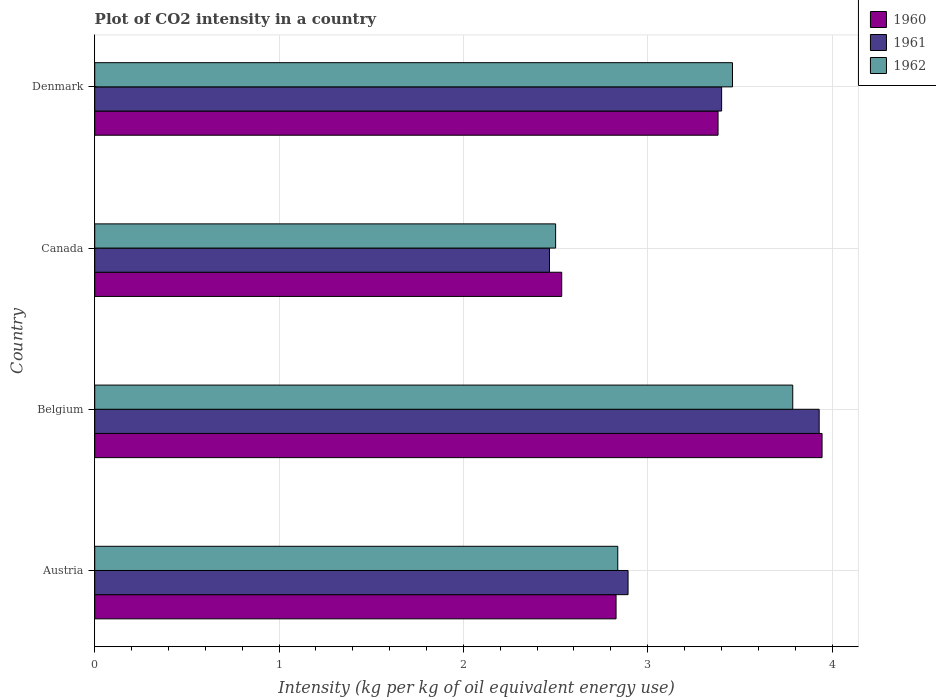How many groups of bars are there?
Give a very brief answer. 4. Are the number of bars per tick equal to the number of legend labels?
Make the answer very short. Yes. Are the number of bars on each tick of the Y-axis equal?
Provide a succinct answer. Yes. How many bars are there on the 4th tick from the bottom?
Give a very brief answer. 3. What is the CO2 intensity in in 1960 in Austria?
Your answer should be compact. 2.83. Across all countries, what is the maximum CO2 intensity in in 1962?
Offer a very short reply. 3.79. Across all countries, what is the minimum CO2 intensity in in 1962?
Provide a succinct answer. 2.5. In which country was the CO2 intensity in in 1960 maximum?
Ensure brevity in your answer.  Belgium. In which country was the CO2 intensity in in 1960 minimum?
Your answer should be compact. Canada. What is the total CO2 intensity in in 1961 in the graph?
Offer a very short reply. 12.69. What is the difference between the CO2 intensity in in 1961 in Austria and that in Belgium?
Keep it short and to the point. -1.04. What is the difference between the CO2 intensity in in 1960 in Denmark and the CO2 intensity in in 1962 in Belgium?
Your response must be concise. -0.41. What is the average CO2 intensity in in 1962 per country?
Your answer should be compact. 3.15. What is the difference between the CO2 intensity in in 1960 and CO2 intensity in in 1961 in Austria?
Provide a succinct answer. -0.07. In how many countries, is the CO2 intensity in in 1960 greater than 1.4 kg?
Your answer should be compact. 4. What is the ratio of the CO2 intensity in in 1960 in Austria to that in Canada?
Provide a short and direct response. 1.12. Is the CO2 intensity in in 1961 in Austria less than that in Belgium?
Keep it short and to the point. Yes. Is the difference between the CO2 intensity in in 1960 in Austria and Canada greater than the difference between the CO2 intensity in in 1961 in Austria and Canada?
Provide a succinct answer. No. What is the difference between the highest and the second highest CO2 intensity in in 1962?
Provide a succinct answer. 0.33. What is the difference between the highest and the lowest CO2 intensity in in 1960?
Keep it short and to the point. 1.41. Is it the case that in every country, the sum of the CO2 intensity in in 1960 and CO2 intensity in in 1962 is greater than the CO2 intensity in in 1961?
Your answer should be very brief. Yes. Are all the bars in the graph horizontal?
Offer a terse response. Yes. How many countries are there in the graph?
Keep it short and to the point. 4. What is the difference between two consecutive major ticks on the X-axis?
Ensure brevity in your answer.  1. Are the values on the major ticks of X-axis written in scientific E-notation?
Make the answer very short. No. Does the graph contain any zero values?
Offer a terse response. No. Where does the legend appear in the graph?
Give a very brief answer. Top right. What is the title of the graph?
Ensure brevity in your answer.  Plot of CO2 intensity in a country. What is the label or title of the X-axis?
Your answer should be very brief. Intensity (kg per kg of oil equivalent energy use). What is the Intensity (kg per kg of oil equivalent energy use) of 1960 in Austria?
Provide a short and direct response. 2.83. What is the Intensity (kg per kg of oil equivalent energy use) in 1961 in Austria?
Provide a succinct answer. 2.89. What is the Intensity (kg per kg of oil equivalent energy use) of 1962 in Austria?
Offer a terse response. 2.84. What is the Intensity (kg per kg of oil equivalent energy use) of 1960 in Belgium?
Provide a succinct answer. 3.95. What is the Intensity (kg per kg of oil equivalent energy use) of 1961 in Belgium?
Keep it short and to the point. 3.93. What is the Intensity (kg per kg of oil equivalent energy use) of 1962 in Belgium?
Your answer should be compact. 3.79. What is the Intensity (kg per kg of oil equivalent energy use) in 1960 in Canada?
Your answer should be very brief. 2.53. What is the Intensity (kg per kg of oil equivalent energy use) of 1961 in Canada?
Your answer should be compact. 2.47. What is the Intensity (kg per kg of oil equivalent energy use) of 1962 in Canada?
Your response must be concise. 2.5. What is the Intensity (kg per kg of oil equivalent energy use) in 1960 in Denmark?
Offer a very short reply. 3.38. What is the Intensity (kg per kg of oil equivalent energy use) in 1961 in Denmark?
Your response must be concise. 3.4. What is the Intensity (kg per kg of oil equivalent energy use) of 1962 in Denmark?
Offer a very short reply. 3.46. Across all countries, what is the maximum Intensity (kg per kg of oil equivalent energy use) in 1960?
Your response must be concise. 3.95. Across all countries, what is the maximum Intensity (kg per kg of oil equivalent energy use) of 1961?
Ensure brevity in your answer.  3.93. Across all countries, what is the maximum Intensity (kg per kg of oil equivalent energy use) of 1962?
Provide a short and direct response. 3.79. Across all countries, what is the minimum Intensity (kg per kg of oil equivalent energy use) of 1960?
Ensure brevity in your answer.  2.53. Across all countries, what is the minimum Intensity (kg per kg of oil equivalent energy use) in 1961?
Make the answer very short. 2.47. Across all countries, what is the minimum Intensity (kg per kg of oil equivalent energy use) of 1962?
Give a very brief answer. 2.5. What is the total Intensity (kg per kg of oil equivalent energy use) in 1960 in the graph?
Provide a succinct answer. 12.69. What is the total Intensity (kg per kg of oil equivalent energy use) in 1961 in the graph?
Provide a succinct answer. 12.69. What is the total Intensity (kg per kg of oil equivalent energy use) of 1962 in the graph?
Ensure brevity in your answer.  12.58. What is the difference between the Intensity (kg per kg of oil equivalent energy use) in 1960 in Austria and that in Belgium?
Give a very brief answer. -1.12. What is the difference between the Intensity (kg per kg of oil equivalent energy use) of 1961 in Austria and that in Belgium?
Your response must be concise. -1.04. What is the difference between the Intensity (kg per kg of oil equivalent energy use) of 1962 in Austria and that in Belgium?
Your answer should be compact. -0.95. What is the difference between the Intensity (kg per kg of oil equivalent energy use) of 1960 in Austria and that in Canada?
Your response must be concise. 0.29. What is the difference between the Intensity (kg per kg of oil equivalent energy use) in 1961 in Austria and that in Canada?
Give a very brief answer. 0.43. What is the difference between the Intensity (kg per kg of oil equivalent energy use) of 1962 in Austria and that in Canada?
Provide a succinct answer. 0.34. What is the difference between the Intensity (kg per kg of oil equivalent energy use) of 1960 in Austria and that in Denmark?
Make the answer very short. -0.55. What is the difference between the Intensity (kg per kg of oil equivalent energy use) in 1961 in Austria and that in Denmark?
Give a very brief answer. -0.51. What is the difference between the Intensity (kg per kg of oil equivalent energy use) in 1962 in Austria and that in Denmark?
Provide a short and direct response. -0.62. What is the difference between the Intensity (kg per kg of oil equivalent energy use) of 1960 in Belgium and that in Canada?
Offer a terse response. 1.41. What is the difference between the Intensity (kg per kg of oil equivalent energy use) of 1961 in Belgium and that in Canada?
Offer a terse response. 1.46. What is the difference between the Intensity (kg per kg of oil equivalent energy use) in 1962 in Belgium and that in Canada?
Your response must be concise. 1.29. What is the difference between the Intensity (kg per kg of oil equivalent energy use) of 1960 in Belgium and that in Denmark?
Provide a succinct answer. 0.56. What is the difference between the Intensity (kg per kg of oil equivalent energy use) in 1961 in Belgium and that in Denmark?
Your answer should be very brief. 0.53. What is the difference between the Intensity (kg per kg of oil equivalent energy use) in 1962 in Belgium and that in Denmark?
Make the answer very short. 0.33. What is the difference between the Intensity (kg per kg of oil equivalent energy use) of 1960 in Canada and that in Denmark?
Ensure brevity in your answer.  -0.85. What is the difference between the Intensity (kg per kg of oil equivalent energy use) in 1961 in Canada and that in Denmark?
Give a very brief answer. -0.93. What is the difference between the Intensity (kg per kg of oil equivalent energy use) in 1962 in Canada and that in Denmark?
Make the answer very short. -0.96. What is the difference between the Intensity (kg per kg of oil equivalent energy use) of 1960 in Austria and the Intensity (kg per kg of oil equivalent energy use) of 1961 in Belgium?
Offer a terse response. -1.1. What is the difference between the Intensity (kg per kg of oil equivalent energy use) in 1960 in Austria and the Intensity (kg per kg of oil equivalent energy use) in 1962 in Belgium?
Keep it short and to the point. -0.96. What is the difference between the Intensity (kg per kg of oil equivalent energy use) of 1961 in Austria and the Intensity (kg per kg of oil equivalent energy use) of 1962 in Belgium?
Your answer should be compact. -0.89. What is the difference between the Intensity (kg per kg of oil equivalent energy use) in 1960 in Austria and the Intensity (kg per kg of oil equivalent energy use) in 1961 in Canada?
Give a very brief answer. 0.36. What is the difference between the Intensity (kg per kg of oil equivalent energy use) in 1960 in Austria and the Intensity (kg per kg of oil equivalent energy use) in 1962 in Canada?
Offer a terse response. 0.33. What is the difference between the Intensity (kg per kg of oil equivalent energy use) of 1961 in Austria and the Intensity (kg per kg of oil equivalent energy use) of 1962 in Canada?
Your answer should be very brief. 0.39. What is the difference between the Intensity (kg per kg of oil equivalent energy use) of 1960 in Austria and the Intensity (kg per kg of oil equivalent energy use) of 1961 in Denmark?
Offer a very short reply. -0.57. What is the difference between the Intensity (kg per kg of oil equivalent energy use) of 1960 in Austria and the Intensity (kg per kg of oil equivalent energy use) of 1962 in Denmark?
Provide a succinct answer. -0.63. What is the difference between the Intensity (kg per kg of oil equivalent energy use) in 1961 in Austria and the Intensity (kg per kg of oil equivalent energy use) in 1962 in Denmark?
Offer a terse response. -0.57. What is the difference between the Intensity (kg per kg of oil equivalent energy use) of 1960 in Belgium and the Intensity (kg per kg of oil equivalent energy use) of 1961 in Canada?
Make the answer very short. 1.48. What is the difference between the Intensity (kg per kg of oil equivalent energy use) in 1960 in Belgium and the Intensity (kg per kg of oil equivalent energy use) in 1962 in Canada?
Offer a very short reply. 1.45. What is the difference between the Intensity (kg per kg of oil equivalent energy use) in 1961 in Belgium and the Intensity (kg per kg of oil equivalent energy use) in 1962 in Canada?
Offer a terse response. 1.43. What is the difference between the Intensity (kg per kg of oil equivalent energy use) in 1960 in Belgium and the Intensity (kg per kg of oil equivalent energy use) in 1961 in Denmark?
Ensure brevity in your answer.  0.54. What is the difference between the Intensity (kg per kg of oil equivalent energy use) of 1960 in Belgium and the Intensity (kg per kg of oil equivalent energy use) of 1962 in Denmark?
Your answer should be very brief. 0.49. What is the difference between the Intensity (kg per kg of oil equivalent energy use) in 1961 in Belgium and the Intensity (kg per kg of oil equivalent energy use) in 1962 in Denmark?
Offer a terse response. 0.47. What is the difference between the Intensity (kg per kg of oil equivalent energy use) in 1960 in Canada and the Intensity (kg per kg of oil equivalent energy use) in 1961 in Denmark?
Offer a very short reply. -0.87. What is the difference between the Intensity (kg per kg of oil equivalent energy use) in 1960 in Canada and the Intensity (kg per kg of oil equivalent energy use) in 1962 in Denmark?
Keep it short and to the point. -0.93. What is the difference between the Intensity (kg per kg of oil equivalent energy use) in 1961 in Canada and the Intensity (kg per kg of oil equivalent energy use) in 1962 in Denmark?
Your answer should be compact. -0.99. What is the average Intensity (kg per kg of oil equivalent energy use) in 1960 per country?
Keep it short and to the point. 3.17. What is the average Intensity (kg per kg of oil equivalent energy use) in 1961 per country?
Keep it short and to the point. 3.17. What is the average Intensity (kg per kg of oil equivalent energy use) in 1962 per country?
Make the answer very short. 3.15. What is the difference between the Intensity (kg per kg of oil equivalent energy use) in 1960 and Intensity (kg per kg of oil equivalent energy use) in 1961 in Austria?
Provide a succinct answer. -0.07. What is the difference between the Intensity (kg per kg of oil equivalent energy use) of 1960 and Intensity (kg per kg of oil equivalent energy use) of 1962 in Austria?
Ensure brevity in your answer.  -0.01. What is the difference between the Intensity (kg per kg of oil equivalent energy use) in 1961 and Intensity (kg per kg of oil equivalent energy use) in 1962 in Austria?
Make the answer very short. 0.06. What is the difference between the Intensity (kg per kg of oil equivalent energy use) in 1960 and Intensity (kg per kg of oil equivalent energy use) in 1961 in Belgium?
Your answer should be compact. 0.02. What is the difference between the Intensity (kg per kg of oil equivalent energy use) in 1960 and Intensity (kg per kg of oil equivalent energy use) in 1962 in Belgium?
Give a very brief answer. 0.16. What is the difference between the Intensity (kg per kg of oil equivalent energy use) in 1961 and Intensity (kg per kg of oil equivalent energy use) in 1962 in Belgium?
Offer a terse response. 0.14. What is the difference between the Intensity (kg per kg of oil equivalent energy use) in 1960 and Intensity (kg per kg of oil equivalent energy use) in 1961 in Canada?
Offer a terse response. 0.07. What is the difference between the Intensity (kg per kg of oil equivalent energy use) of 1960 and Intensity (kg per kg of oil equivalent energy use) of 1962 in Canada?
Your answer should be compact. 0.03. What is the difference between the Intensity (kg per kg of oil equivalent energy use) in 1961 and Intensity (kg per kg of oil equivalent energy use) in 1962 in Canada?
Your response must be concise. -0.03. What is the difference between the Intensity (kg per kg of oil equivalent energy use) in 1960 and Intensity (kg per kg of oil equivalent energy use) in 1961 in Denmark?
Provide a succinct answer. -0.02. What is the difference between the Intensity (kg per kg of oil equivalent energy use) of 1960 and Intensity (kg per kg of oil equivalent energy use) of 1962 in Denmark?
Offer a very short reply. -0.08. What is the difference between the Intensity (kg per kg of oil equivalent energy use) in 1961 and Intensity (kg per kg of oil equivalent energy use) in 1962 in Denmark?
Your response must be concise. -0.06. What is the ratio of the Intensity (kg per kg of oil equivalent energy use) of 1960 in Austria to that in Belgium?
Your answer should be very brief. 0.72. What is the ratio of the Intensity (kg per kg of oil equivalent energy use) in 1961 in Austria to that in Belgium?
Your response must be concise. 0.74. What is the ratio of the Intensity (kg per kg of oil equivalent energy use) of 1962 in Austria to that in Belgium?
Provide a succinct answer. 0.75. What is the ratio of the Intensity (kg per kg of oil equivalent energy use) in 1960 in Austria to that in Canada?
Keep it short and to the point. 1.12. What is the ratio of the Intensity (kg per kg of oil equivalent energy use) of 1961 in Austria to that in Canada?
Offer a terse response. 1.17. What is the ratio of the Intensity (kg per kg of oil equivalent energy use) of 1962 in Austria to that in Canada?
Your response must be concise. 1.13. What is the ratio of the Intensity (kg per kg of oil equivalent energy use) in 1960 in Austria to that in Denmark?
Your response must be concise. 0.84. What is the ratio of the Intensity (kg per kg of oil equivalent energy use) of 1961 in Austria to that in Denmark?
Make the answer very short. 0.85. What is the ratio of the Intensity (kg per kg of oil equivalent energy use) in 1962 in Austria to that in Denmark?
Your response must be concise. 0.82. What is the ratio of the Intensity (kg per kg of oil equivalent energy use) in 1960 in Belgium to that in Canada?
Make the answer very short. 1.56. What is the ratio of the Intensity (kg per kg of oil equivalent energy use) of 1961 in Belgium to that in Canada?
Offer a very short reply. 1.59. What is the ratio of the Intensity (kg per kg of oil equivalent energy use) in 1962 in Belgium to that in Canada?
Your response must be concise. 1.51. What is the ratio of the Intensity (kg per kg of oil equivalent energy use) of 1960 in Belgium to that in Denmark?
Provide a short and direct response. 1.17. What is the ratio of the Intensity (kg per kg of oil equivalent energy use) in 1961 in Belgium to that in Denmark?
Your answer should be very brief. 1.16. What is the ratio of the Intensity (kg per kg of oil equivalent energy use) of 1962 in Belgium to that in Denmark?
Ensure brevity in your answer.  1.09. What is the ratio of the Intensity (kg per kg of oil equivalent energy use) of 1960 in Canada to that in Denmark?
Provide a succinct answer. 0.75. What is the ratio of the Intensity (kg per kg of oil equivalent energy use) of 1961 in Canada to that in Denmark?
Keep it short and to the point. 0.73. What is the ratio of the Intensity (kg per kg of oil equivalent energy use) of 1962 in Canada to that in Denmark?
Your answer should be compact. 0.72. What is the difference between the highest and the second highest Intensity (kg per kg of oil equivalent energy use) of 1960?
Ensure brevity in your answer.  0.56. What is the difference between the highest and the second highest Intensity (kg per kg of oil equivalent energy use) of 1961?
Offer a very short reply. 0.53. What is the difference between the highest and the second highest Intensity (kg per kg of oil equivalent energy use) of 1962?
Your answer should be compact. 0.33. What is the difference between the highest and the lowest Intensity (kg per kg of oil equivalent energy use) of 1960?
Provide a succinct answer. 1.41. What is the difference between the highest and the lowest Intensity (kg per kg of oil equivalent energy use) of 1961?
Ensure brevity in your answer.  1.46. What is the difference between the highest and the lowest Intensity (kg per kg of oil equivalent energy use) of 1962?
Provide a succinct answer. 1.29. 